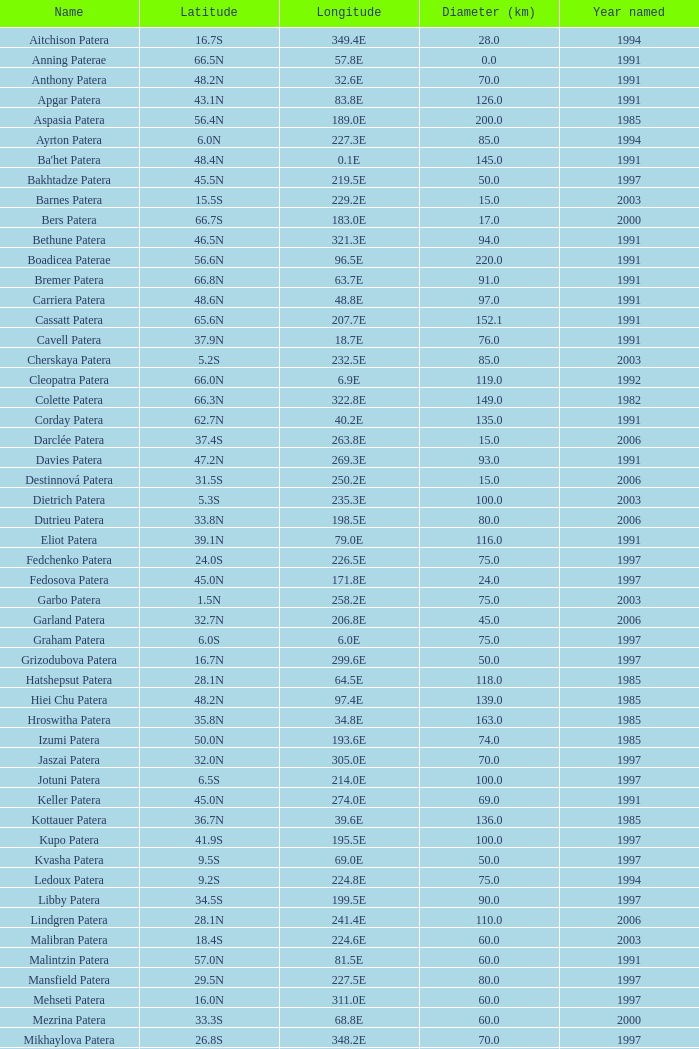What is the mean year named for locations with a latitude of 37.9n and a diameter greater than 76 km? None. 